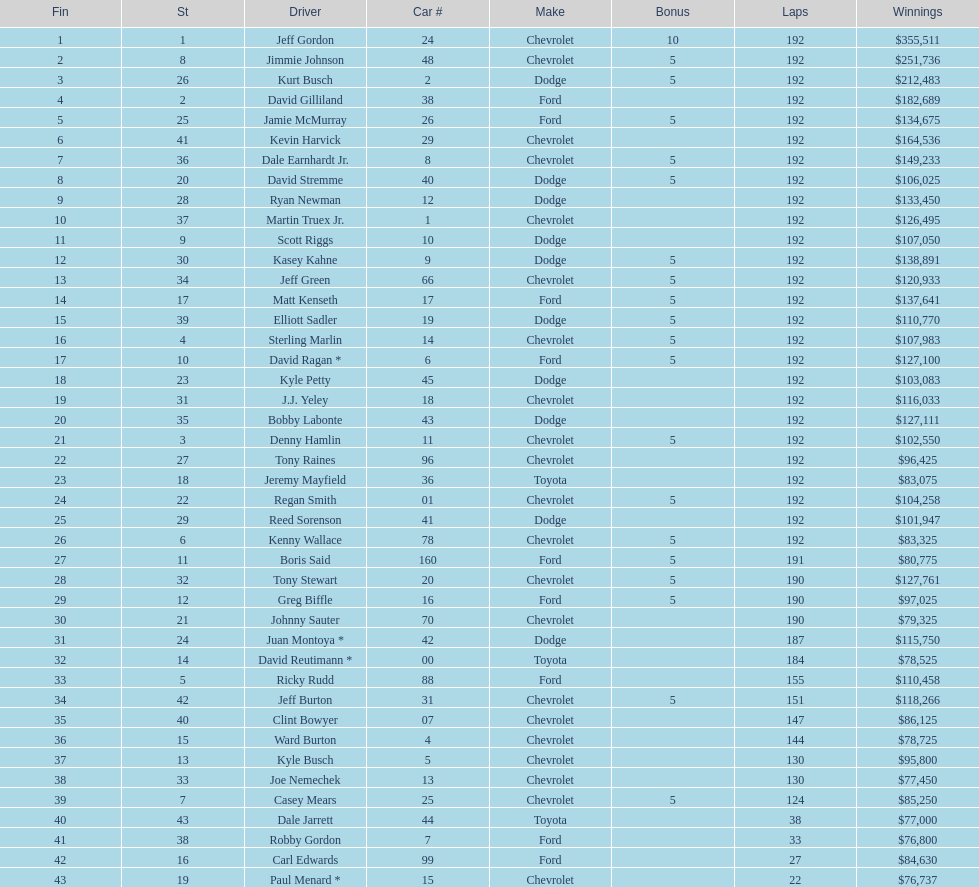How many drivers placed below tony stewart? 15. 